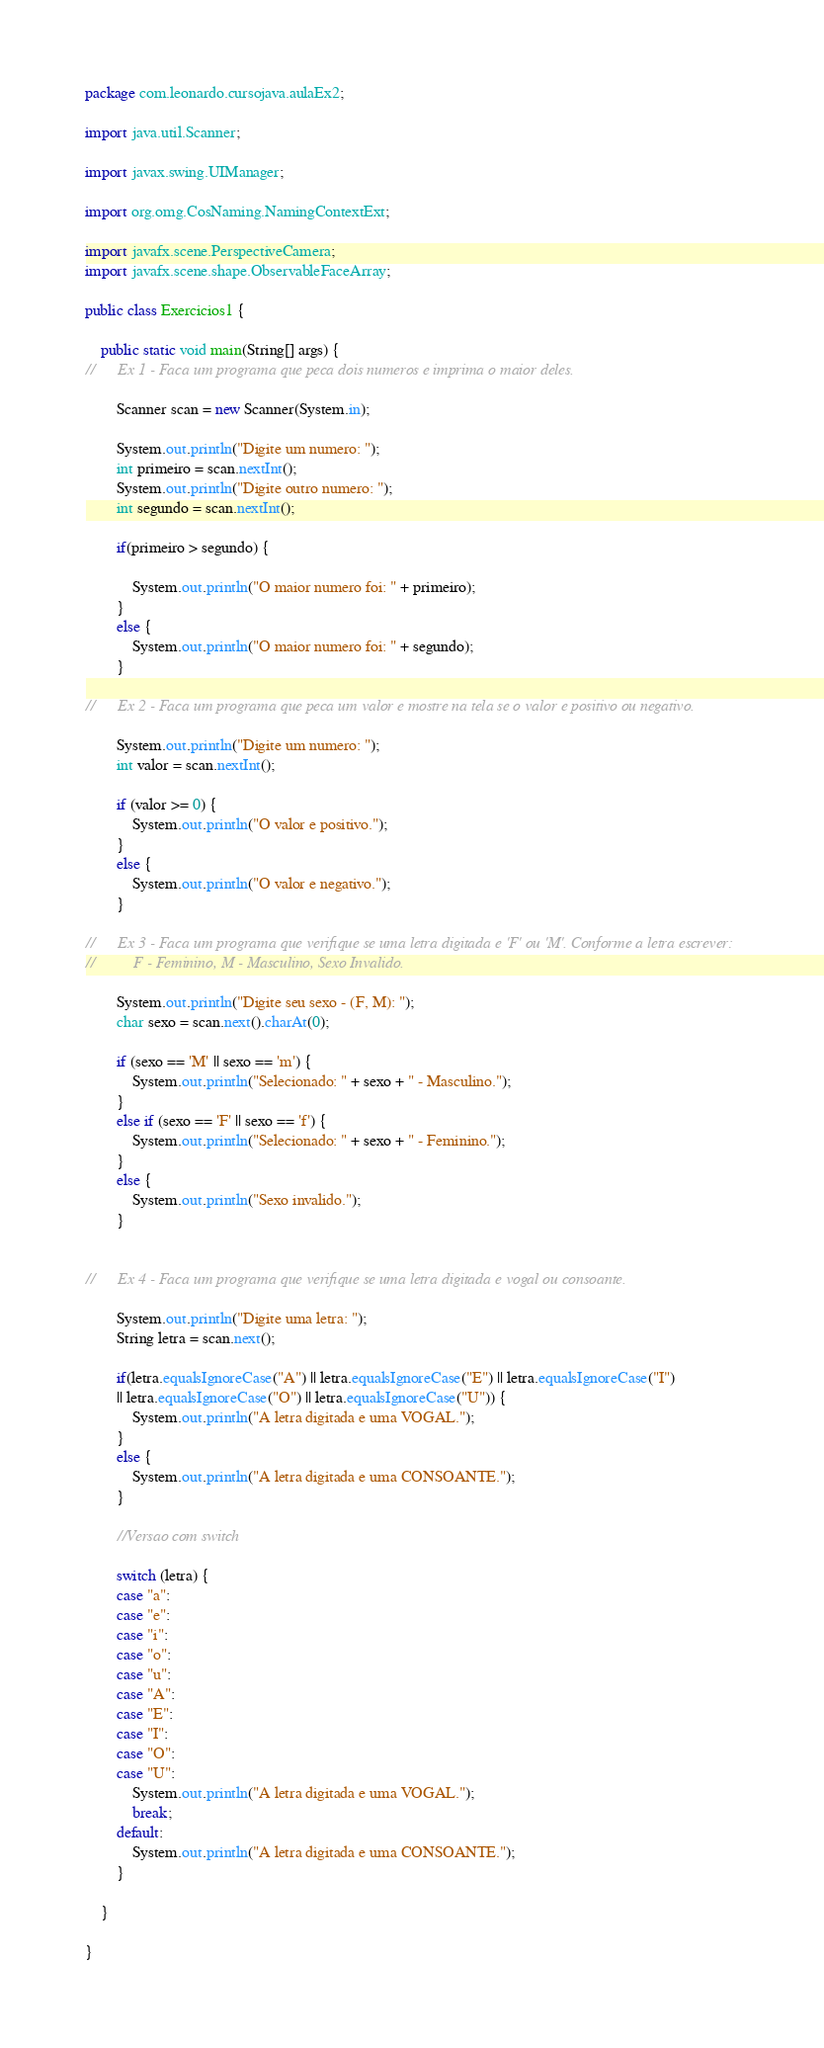<code> <loc_0><loc_0><loc_500><loc_500><_Java_>package com.leonardo.cursojava.aulaEx2;

import java.util.Scanner;

import javax.swing.UIManager;

import org.omg.CosNaming.NamingContextExt;

import javafx.scene.PerspectiveCamera;
import javafx.scene.shape.ObservableFaceArray;

public class Exercicios1 {
	
	public static void main(String[] args) {
//		Ex 1 - Faca um programa que peca dois numeros e imprima o maior deles.
		
		Scanner scan = new Scanner(System.in);

		System.out.println("Digite um numero: ");
		int primeiro = scan.nextInt();
		System.out.println("Digite outro numero: ");
		int segundo = scan.nextInt();
		
		if(primeiro > segundo) {
			
			System.out.println("O maior numero foi: " + primeiro);
		}
		else {
			System.out.println("O maior numero foi: " + segundo);
		}
		
//		Ex 2 - Faca um programa que peca um valor e mostre na tela se o valor e positivo ou negativo.
 		
		System.out.println("Digite um numero: ");
		int valor = scan.nextInt();
		
		if (valor >= 0) {
			System.out.println("O valor e positivo.");
		}
		else {
			System.out.println("O valor e negativo.");
		}
		
//		Ex 3 - Faca um programa que verifique se uma letra digitada e 'F' ou 'M'. Conforme a letra escrever:
//			F - Feminino, M - Masculino, Sexo Invalido.
		
		System.out.println("Digite seu sexo - (F, M): ");
		char sexo = scan.next().charAt(0);
		
		if (sexo == 'M' || sexo == 'm') {
			System.out.println("Selecionado: " + sexo + " - Masculino.");
		}
		else if (sexo == 'F' || sexo == 'f') {
			System.out.println("Selecionado: " + sexo + " - Feminino.");
		}
		else {
			System.out.println("Sexo invalido.");
		}
		
		
//		Ex 4 - Faca um programa que verifique se uma letra digitada e vogal ou consoante.
		
		System.out.println("Digite uma letra: ");
		String letra = scan.next();
		
		if(letra.equalsIgnoreCase("A") || letra.equalsIgnoreCase("E") || letra.equalsIgnoreCase("I")
		|| letra.equalsIgnoreCase("O") || letra.equalsIgnoreCase("U")) {
			System.out.println("A letra digitada e uma VOGAL.");
		}
		else {
			System.out.println("A letra digitada e uma CONSOANTE.");
		}
		
		//Versao com switch
		
		switch (letra) {
		case "a":
		case "e":
		case "i":
		case "o":
		case "u": 
		case "A":
		case "E":
		case "I":
		case "O":
		case "U":
			System.out.println("A letra digitada e uma VOGAL.");
			break;		
		default:
			System.out.println("A letra digitada e uma CONSOANTE.");			
		}
		
 	}

}
</code> 